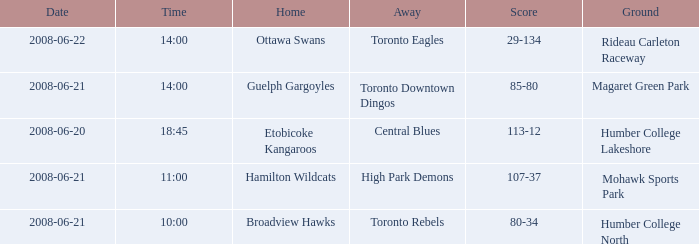What is the date with a house that is hamilton wildcats? 2008-06-21. 